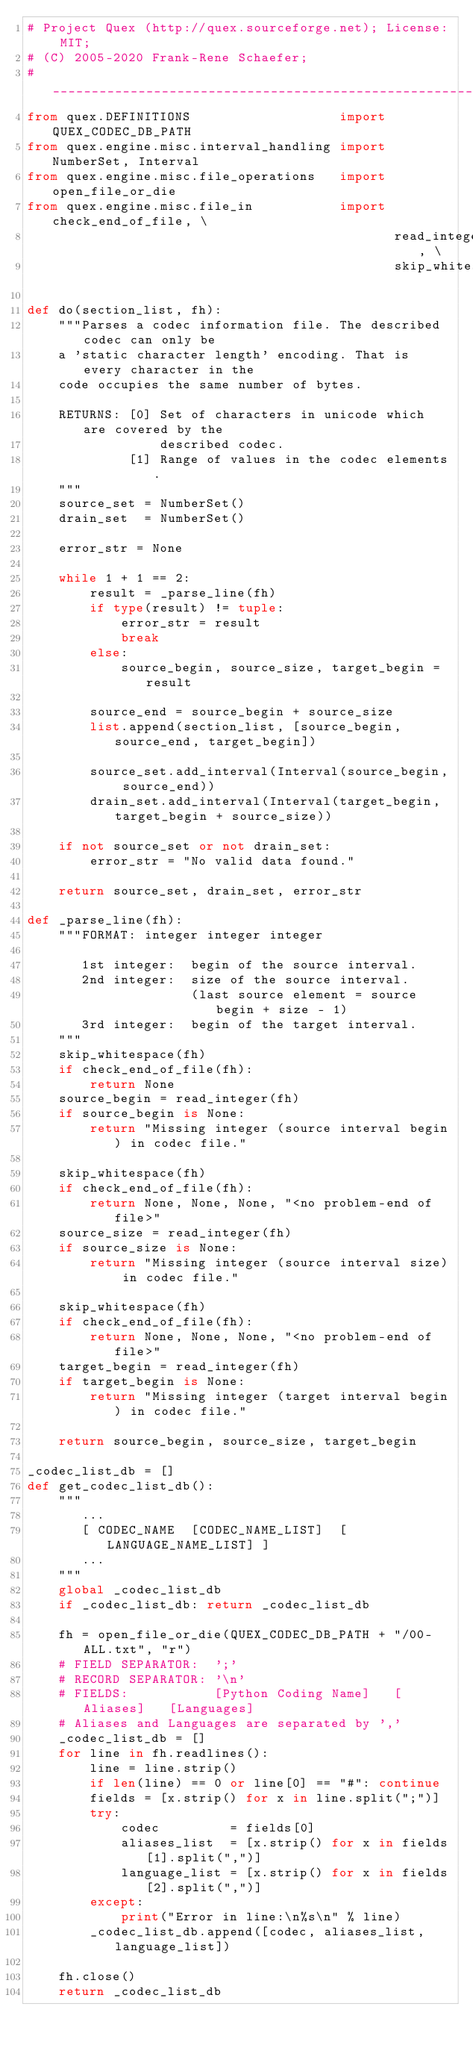<code> <loc_0><loc_0><loc_500><loc_500><_Python_># Project Quex (http://quex.sourceforge.net); License: MIT;
# (C) 2005-2020 Frank-Rene Schaefer; 
#_______________________________________________________________________________
from quex.DEFINITIONS                   import QUEX_CODEC_DB_PATH
from quex.engine.misc.interval_handling import NumberSet, Interval
from quex.engine.misc.file_operations   import open_file_or_die
from quex.engine.misc.file_in           import check_end_of_file, \
                                               read_integer, \
                                               skip_whitespace

def do(section_list, fh):
    """Parses a codec information file. The described codec can only be
    a 'static character length' encoding. That is every character in the
    code occupies the same number of bytes.

    RETURNS: [0] Set of characters in unicode which are covered by the
                 described codec.
             [1] Range of values in the codec elements.
    """
    source_set = NumberSet()
    drain_set  = NumberSet()

    error_str = None

    while 1 + 1 == 2:
        result = _parse_line(fh)
        if type(result) != tuple: 
            error_str = result
            break
        else:
            source_begin, source_size, target_begin = result

        source_end = source_begin + source_size
        list.append(section_list, [source_begin, source_end, target_begin])

        source_set.add_interval(Interval(source_begin, source_end))
        drain_set.add_interval(Interval(target_begin, target_begin + source_size))

    if not source_set or not drain_set:
        error_str = "No valid data found."

    return source_set, drain_set, error_str

def _parse_line(fh):
    """FORMAT: integer integer integer

       1st integer:  begin of the source interval.
       2nd integer:  size of the source interval.
                     (last source element = source begin + size - 1)
       3rd integer:  begin of the target interval.
    """
    skip_whitespace(fh)
    if check_end_of_file(fh): 
        return None
    source_begin = read_integer(fh)
    if source_begin is None:
        return "Missing integer (source interval begin) in codec file."

    skip_whitespace(fh)
    if check_end_of_file(fh):
        return None, None, None, "<no problem-end of file>"
    source_size = read_integer(fh)
    if source_size is None:
        return "Missing integer (source interval size) in codec file." 

    skip_whitespace(fh)
    if check_end_of_file(fh): 
        return None, None, None, "<no problem-end of file>"
    target_begin = read_integer(fh)
    if target_begin is None:
        return "Missing integer (target interval begin) in codec file."

    return source_begin, source_size, target_begin

_codec_list_db = []
def get_codec_list_db():
    """
       ...
       [ CODEC_NAME  [CODEC_NAME_LIST]  [LANGUAGE_NAME_LIST] ]
       ...
    """
    global _codec_list_db
    if _codec_list_db: return _codec_list_db

    fh = open_file_or_die(QUEX_CODEC_DB_PATH + "/00-ALL.txt", "r")
    # FIELD SEPARATOR:  ';'
    # RECORD SEPARATOR: '\n'
    # FIELDS:           [Python Coding Name]   [Aliases]   [Languages] 
    # Aliases and Languages are separated by ','
    _codec_list_db = []
    for line in fh.readlines():
        line = line.strip()
        if len(line) == 0 or line[0] == "#": continue
        fields = [x.strip() for x in line.split(";")]
        try:
            codec         = fields[0]
            aliases_list  = [x.strip() for x in fields[1].split(",")]
            language_list = [x.strip() for x in fields[2].split(",")]
        except:
            print("Error in line:\n%s\n" % line)
        _codec_list_db.append([codec, aliases_list, language_list])

    fh.close()
    return _codec_list_db

</code> 